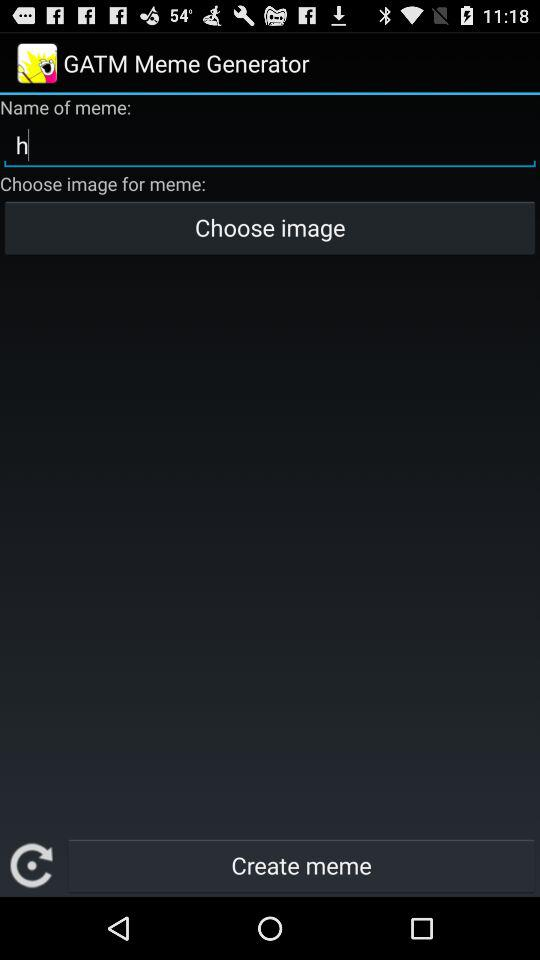What is the name of the meme? The name of the meme is h. 